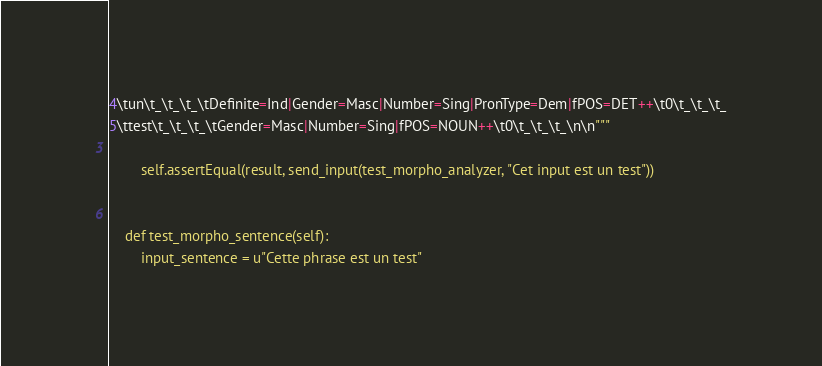Convert code to text. <code><loc_0><loc_0><loc_500><loc_500><_Python_>4\tun\t_\t_\t_\tDefinite=Ind|Gender=Masc|Number=Sing|PronType=Dem|fPOS=DET++\t0\t_\t_\t_
5\ttest\t_\t_\t_\tGender=Masc|Number=Sing|fPOS=NOUN++\t0\t_\t_\t_\n\n"""

        self.assertEqual(result, send_input(test_morpho_analyzer, "Cet input est un test"))


    def test_morpho_sentence(self):
        input_sentence = u"Cette phrase est un test"</code> 